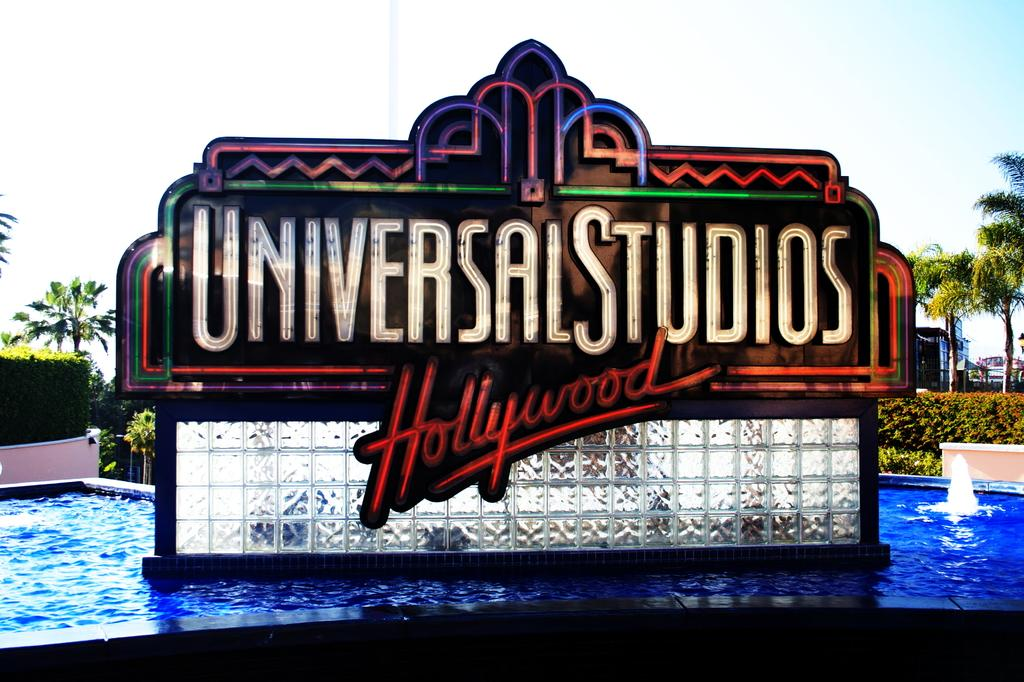What is the main object in the image? There is a board in the image. What can be seen in the background of the image? There is water visible in the image. What type of vegetation is present in the image? There are trees and plants in the image. What type of organization is depicted on the board in the image? There is no organization depicted on the board in the image. Is there a scarf visible in the image? There is no scarf present in the image. Can you see any worms in the image? There is no mention of worms in the image, and therefore no such creatures can be observed. 